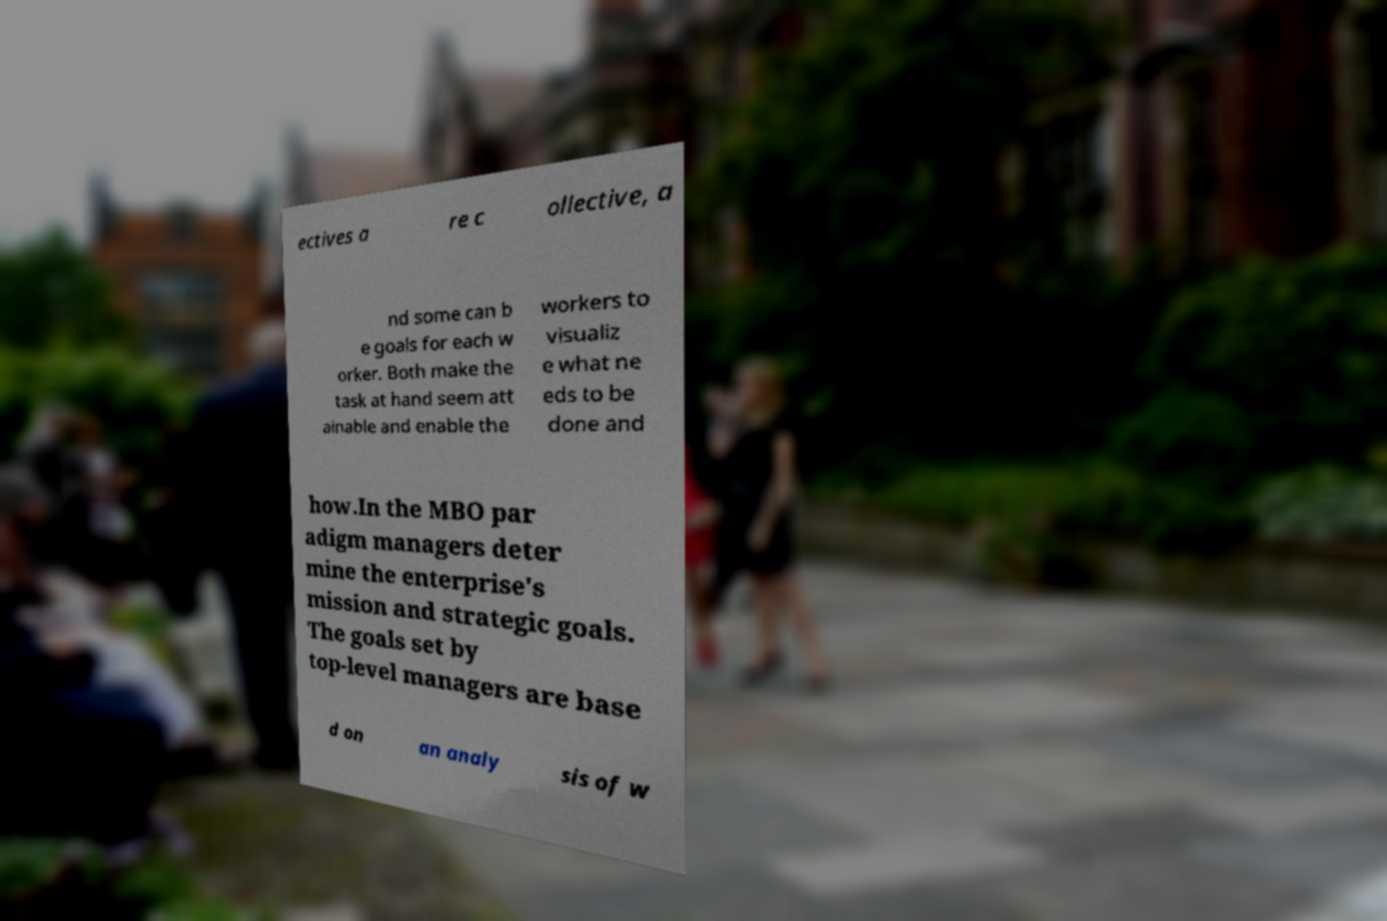Can you read and provide the text displayed in the image?This photo seems to have some interesting text. Can you extract and type it out for me? ectives a re c ollective, a nd some can b e goals for each w orker. Both make the task at hand seem att ainable and enable the workers to visualiz e what ne eds to be done and how.In the MBO par adigm managers deter mine the enterprise's mission and strategic goals. The goals set by top-level managers are base d on an analy sis of w 